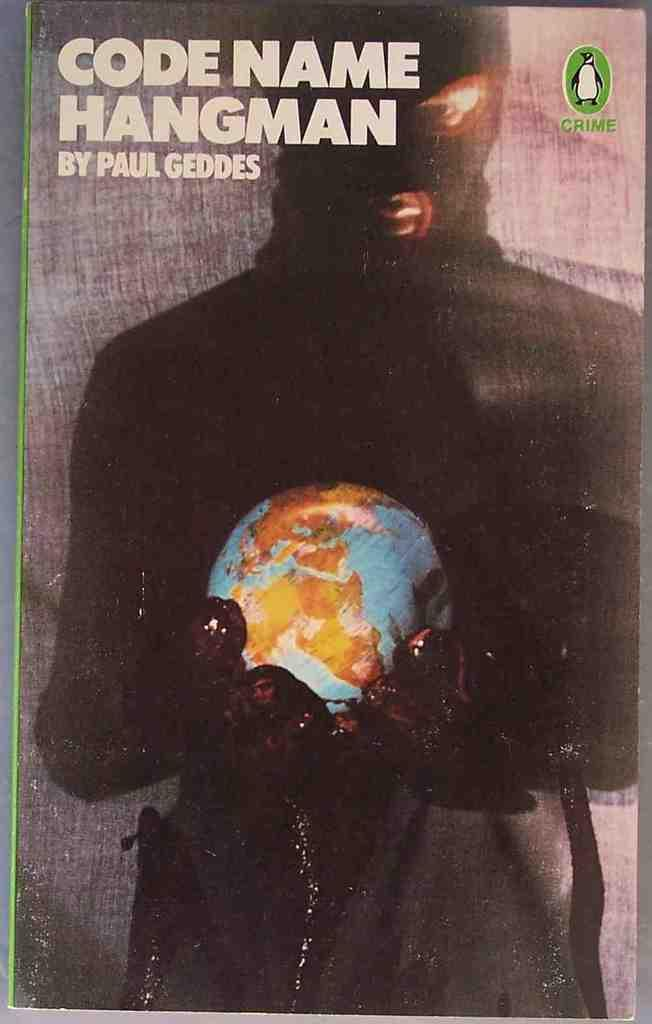<image>
Provide a brief description of the given image. A book by Paul Geddes has a globe on the front. 